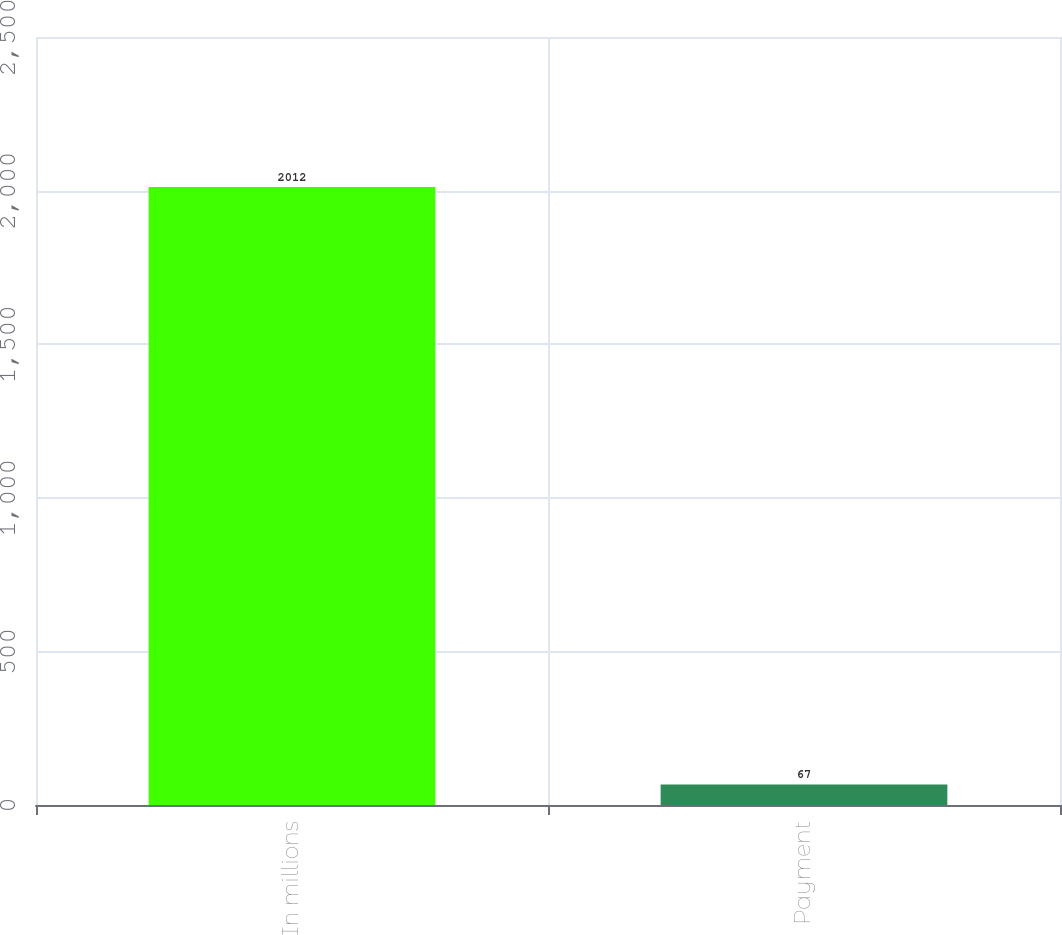Convert chart to OTSL. <chart><loc_0><loc_0><loc_500><loc_500><bar_chart><fcel>In millions<fcel>Payment<nl><fcel>2012<fcel>67<nl></chart> 